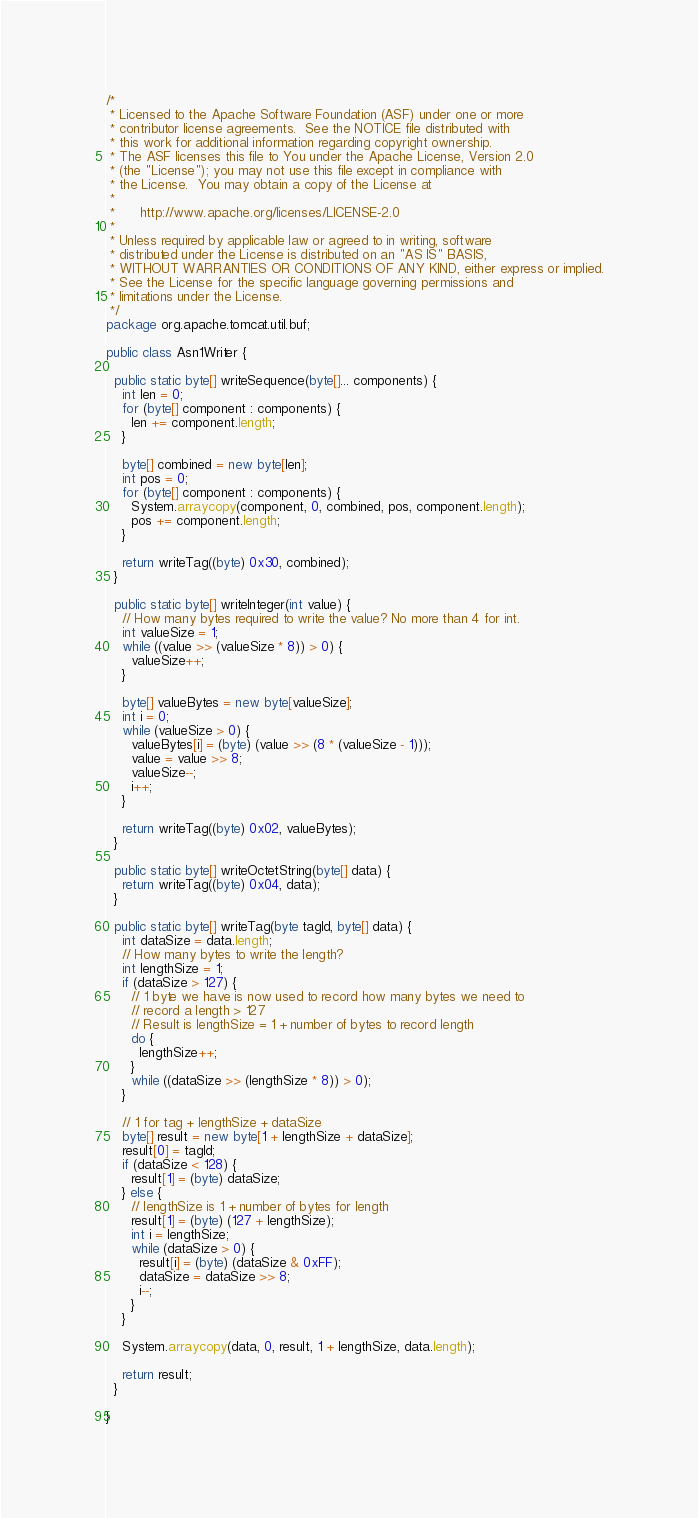Convert code to text. <code><loc_0><loc_0><loc_500><loc_500><_Java_>/*
 * Licensed to the Apache Software Foundation (ASF) under one or more
 * contributor license agreements.  See the NOTICE file distributed with
 * this work for additional information regarding copyright ownership.
 * The ASF licenses this file to You under the Apache License, Version 2.0
 * (the "License"); you may not use this file except in compliance with
 * the License.  You may obtain a copy of the License at
 *
 *      http://www.apache.org/licenses/LICENSE-2.0
 *
 * Unless required by applicable law or agreed to in writing, software
 * distributed under the License is distributed on an "AS IS" BASIS,
 * WITHOUT WARRANTIES OR CONDITIONS OF ANY KIND, either express or implied.
 * See the License for the specific language governing permissions and
 * limitations under the License.
 */
package org.apache.tomcat.util.buf;

public class Asn1Writer {
  
  public static byte[] writeSequence(byte[]... components) {
    int len = 0;
    for (byte[] component : components) {
      len += component.length;
    }
    
    byte[] combined = new byte[len];
    int pos = 0;
    for (byte[] component : components) {
      System.arraycopy(component, 0, combined, pos, component.length);
      pos += component.length;
    }
    
    return writeTag((byte) 0x30, combined);
  }
  
  public static byte[] writeInteger(int value) {
    // How many bytes required to write the value? No more than 4 for int.
    int valueSize = 1;
    while ((value >> (valueSize * 8)) > 0) {
      valueSize++;
    }
    
    byte[] valueBytes = new byte[valueSize];
    int i = 0;
    while (valueSize > 0) {
      valueBytes[i] = (byte) (value >> (8 * (valueSize - 1)));
      value = value >> 8;
      valueSize--;
      i++;
    }
    
    return writeTag((byte) 0x02, valueBytes);
  }
  
  public static byte[] writeOctetString(byte[] data) {
    return writeTag((byte) 0x04, data);
  }
  
  public static byte[] writeTag(byte tagId, byte[] data) {
    int dataSize = data.length;
    // How many bytes to write the length?
    int lengthSize = 1;
    if (dataSize > 127) {
      // 1 byte we have is now used to record how many bytes we need to
      // record a length > 127
      // Result is lengthSize = 1 + number of bytes to record length
      do {
        lengthSize++;
      }
      while ((dataSize >> (lengthSize * 8)) > 0);
    }
    
    // 1 for tag + lengthSize + dataSize
    byte[] result = new byte[1 + lengthSize + dataSize];
    result[0] = tagId;
    if (dataSize < 128) {
      result[1] = (byte) dataSize;
    } else {
      // lengthSize is 1 + number of bytes for length
      result[1] = (byte) (127 + lengthSize);
      int i = lengthSize;
      while (dataSize > 0) {
        result[i] = (byte) (dataSize & 0xFF);
        dataSize = dataSize >> 8;
        i--;
      }
    }
    
    System.arraycopy(data, 0, result, 1 + lengthSize, data.length);
    
    return result;
  }
  
}
</code> 